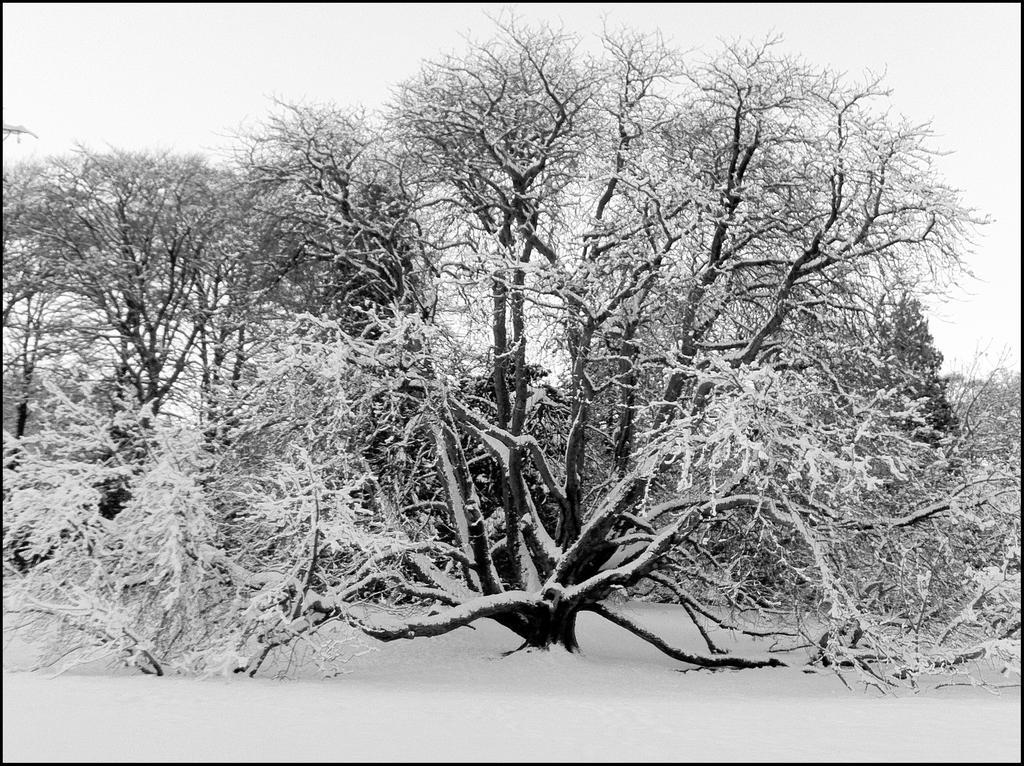Describe this image in one or two sentences. In this picture I can see there are few trees and they are covered with snow and there is snow on the floor. The sky is clear. 